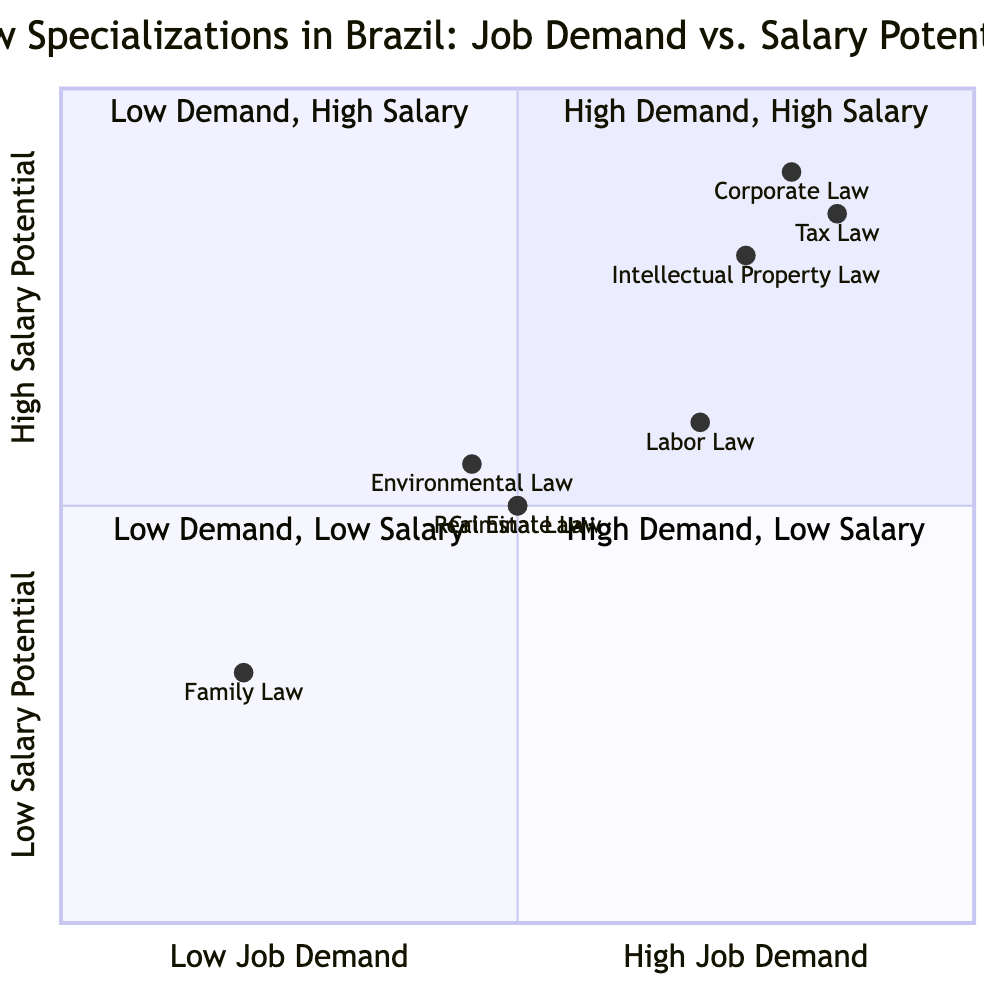What is the specialization located in quadrant 1? Quadrant 1 represents high job demand and high salary potential. Based on the data, the specializations that fall into this quadrant are Corporate Law, Tax Law, and Intellectual Property Law.
Answer: Corporate Law, Tax Law, Intellectual Property Law How many specializations have moderate job demand? The diagram includes specializations with moderate job demand: Criminal Law, Environmental Law, Real Estate Law, and Labor Law. Counting these, there are four specializations in total with moderate job demand.
Answer: 4 Which specialization has low salary potential and low job demand? The quadrant chart indicates that Family Law falls into quadrant 3, which is characterized by low job demand and low salary potential.
Answer: Family Law What is the correlation between job demand and salary potential for Tax Law? For Tax Law, both job demand and salary potential are high, indicating a positive correlation between the two factors for this specialization.
Answer: High Which specialization is in quadrant 4? Quadrant 4 is marked by high job demand and low salary potential. According to the data, Labor Law is positioned in this quadrant.
Answer: Labor Law How many specializations are categorized under high salary potential? To determine how many specializations fall under high salary potential, we look for those in quadrant 1 and quadrant 2. The specializations are Corporate Law, Tax Law, Intellectual Property Law, and Labor Law, totaling four specializations.
Answer: 4 Which specialization has the highest job demand? Corporate Law, Tax Law, Intellectual Property Law, and Labor Law all have high job demand, but Corporate Law is the top one listed in quadrant 1, as it appears first in the data.
Answer: Corporate Law Is there any specialization with low salary potential but high job demand? According to the data, Labor Law is the only specialization that has high job demand (quadrant 4) while having low salary potential.
Answer: Yes, Labor Law 